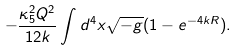Convert formula to latex. <formula><loc_0><loc_0><loc_500><loc_500>- \frac { \kappa _ { 5 } ^ { 2 } Q ^ { 2 } } { 1 2 k } \int d ^ { 4 } x \sqrt { - g } ( 1 - e ^ { - 4 k R } ) .</formula> 